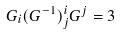<formula> <loc_0><loc_0><loc_500><loc_500>G _ { i } ( G ^ { - 1 } ) ^ { i } _ { j } G ^ { j } = 3</formula> 